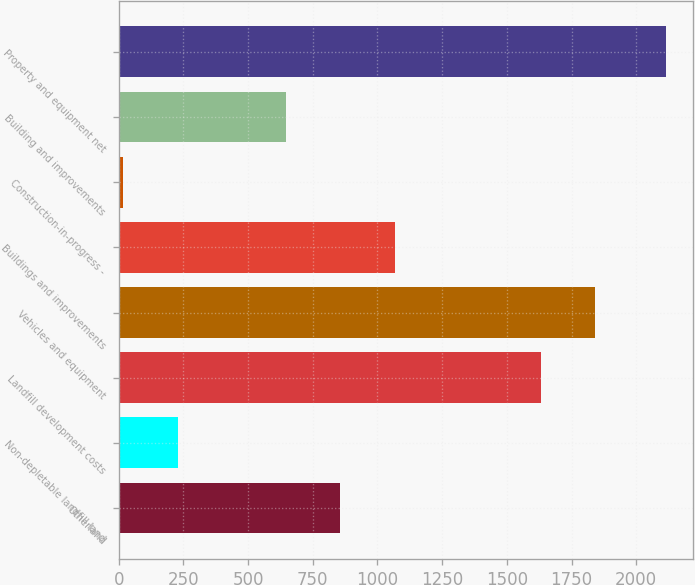Convert chart. <chart><loc_0><loc_0><loc_500><loc_500><bar_chart><fcel>Otherland<fcel>Non-depletable landfill land<fcel>Landfill development costs<fcel>Vehicles and equipment<fcel>Buildings and improvements<fcel>Construction-in-progress -<fcel>Building and improvements<fcel>Property and equipment net<nl><fcel>856.92<fcel>227.73<fcel>1630<fcel>1839.73<fcel>1066.65<fcel>18<fcel>647.19<fcel>2115.3<nl></chart> 